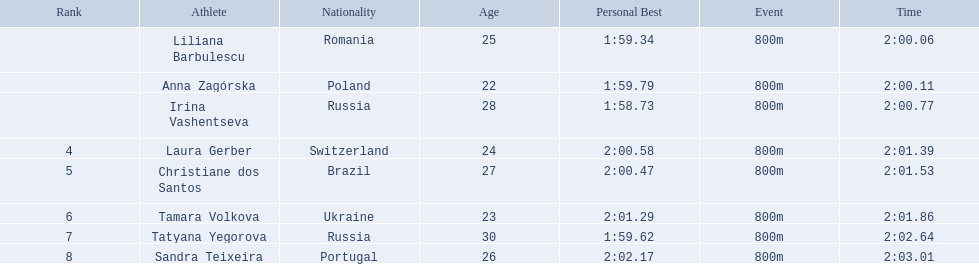Who are all of the athletes? Liliana Barbulescu, Anna Zagórska, Irina Vashentseva, Laura Gerber, Christiane dos Santos, Tamara Volkova, Tatyana Yegorova, Sandra Teixeira. What were their times in the heat? 2:00.06, 2:00.11, 2:00.77, 2:01.39, 2:01.53, 2:01.86, 2:02.64, 2:03.01. Of these, which is the top time? 2:00.06. Which athlete had this time? Liliana Barbulescu. 